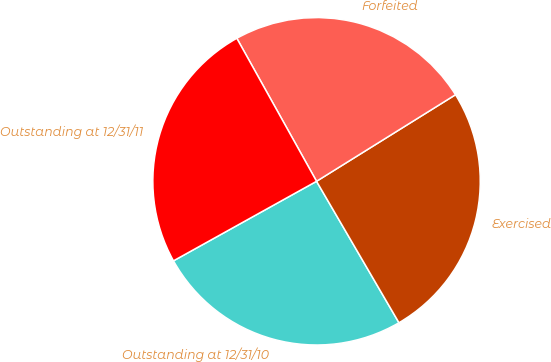Convert chart to OTSL. <chart><loc_0><loc_0><loc_500><loc_500><pie_chart><fcel>Outstanding at 12/31/10<fcel>Exercised<fcel>Forfeited<fcel>Outstanding at 12/31/11<nl><fcel>25.32%<fcel>25.47%<fcel>24.23%<fcel>24.98%<nl></chart> 